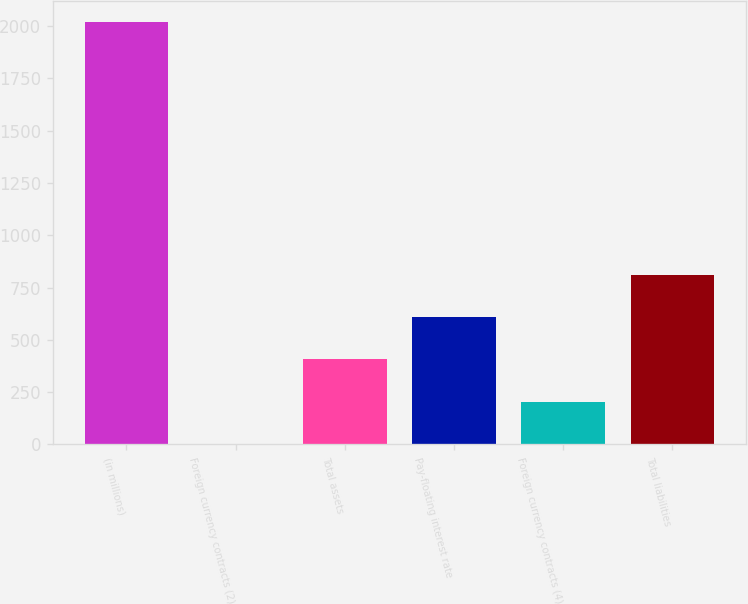Convert chart. <chart><loc_0><loc_0><loc_500><loc_500><bar_chart><fcel>(in millions)<fcel>Foreign currency contracts (2)<fcel>Total assets<fcel>Pay-floating interest rate<fcel>Foreign currency contracts (4)<fcel>Total liabilities<nl><fcel>2018<fcel>3<fcel>406<fcel>607.5<fcel>204.5<fcel>809<nl></chart> 